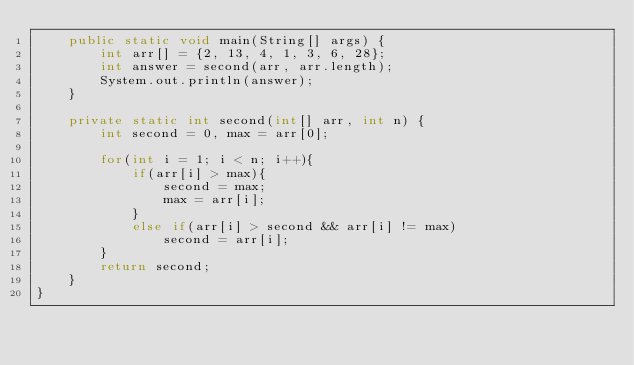Convert code to text. <code><loc_0><loc_0><loc_500><loc_500><_Java_>    public static void main(String[] args) {
        int arr[] = {2, 13, 4, 1, 3, 6, 28};
        int answer = second(arr, arr.length);
        System.out.println(answer);
    }
 
    private static int second(int[] arr, int n) {
        int second = 0, max = arr[0];

        for(int i = 1; i < n; i++){
            if(arr[i] > max){
                second = max;
                max = arr[i];
            }
            else if(arr[i] > second && arr[i] != max)
                second = arr[i];
        }
        return second;
    }
}
</code> 